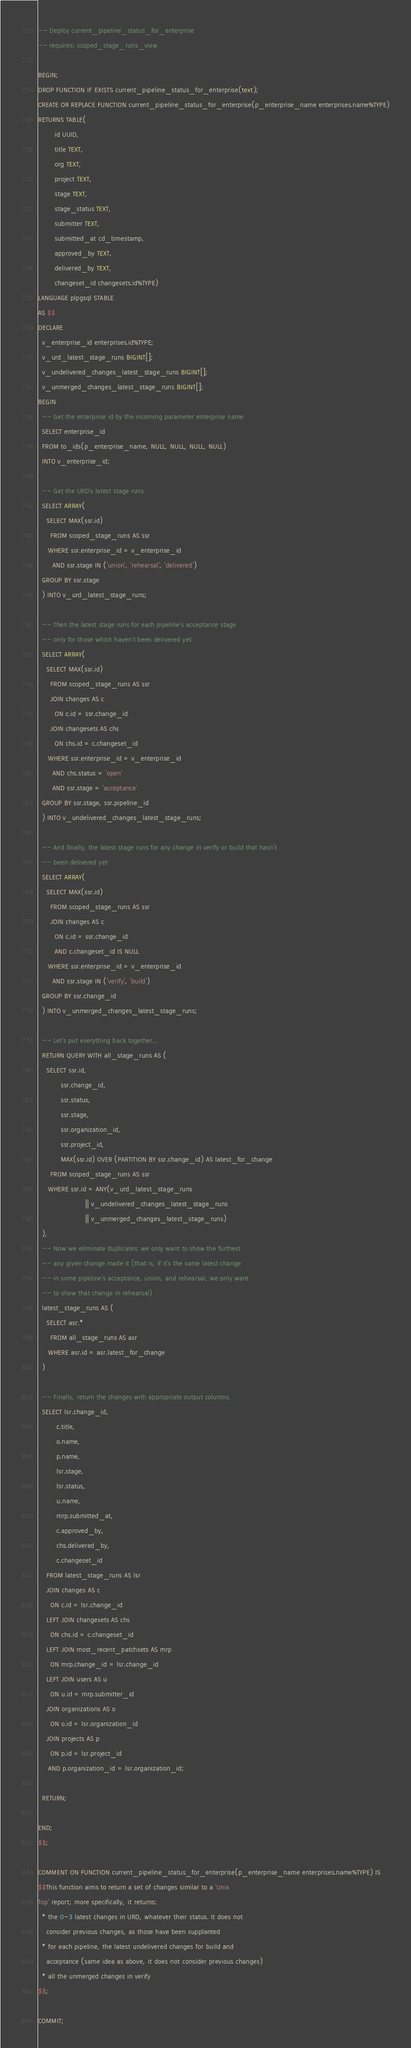<code> <loc_0><loc_0><loc_500><loc_500><_SQL_>-- Deploy current_pipeline_status_for_enterprise
-- requires: scoped_stage_runs_view

BEGIN;
DROP FUNCTION IF EXISTS current_pipeline_status_for_enterprise(text);
CREATE OR REPLACE FUNCTION current_pipeline_status_for_enterprise(p_enterprise_name enterprises.name%TYPE)
RETURNS TABLE(
        id UUID,
        title TEXT,
        org TEXT,
        project TEXT,
        stage TEXT,
        stage_status TEXT,
        submitter TEXT,
        submitted_at cd_timestamp,
        approved_by TEXT,
        delivered_by TEXT,
        changeset_id changesets.id%TYPE)
LANGUAGE plpgsql STABLE
AS $$
DECLARE
  v_enterprise_id enterprises.id%TYPE;
  v_urd_latest_stage_runs BIGINT[];
  v_undelivered_changes_latest_stage_runs BIGINT[];
  v_unmerged_changes_latest_stage_runs BIGINT[];
BEGIN
  -- Get the enterprise id by the incoming parameter enterprise name
  SELECT enterprise_id
  FROM to_ids(p_enterprise_name, NULL, NULL, NULL, NULL)
  INTO v_enterprise_id;

  -- Get the URD's latest stage runs
  SELECT ARRAY(
    SELECT MAX(ssr.id)
      FROM scoped_stage_runs AS ssr
     WHERE ssr.enterprise_id = v_enterprise_id
       AND ssr.stage IN ('union', 'rehearsal', 'delivered')
  GROUP BY ssr.stage
  ) INTO v_urd_latest_stage_runs;

  -- Then the latest stage runs for each pipeline's acceptance stage
  -- only for those which haven't been delivered yet
  SELECT ARRAY(
    SELECT MAX(ssr.id)
      FROM scoped_stage_runs AS ssr
      JOIN changes AS c
        ON c.id = ssr.change_id
      JOIN changesets AS chs
        ON chs.id = c.changeset_id
     WHERE ssr.enterprise_id = v_enterprise_id
       AND chs.status = 'open'
       AND ssr.stage = 'acceptance'
  GROUP BY ssr.stage, ssr.pipeline_id
  ) INTO v_undelivered_changes_latest_stage_runs;

  -- And finally, the latest stage runs for any change in verify or build that hasn't
  -- been delivered yet
  SELECT ARRAY(
    SELECT MAX(ssr.id)
      FROM scoped_stage_runs AS ssr
      JOIN changes AS c
        ON c.id = ssr.change_id
        AND c.changeset_id IS NULL
     WHERE ssr.enterprise_id = v_enterprise_id
       AND ssr.stage IN ('verify', 'build')
  GROUP BY ssr.change_id
  ) INTO v_unmerged_changes_latest_stage_runs;

  -- Let's put everything back together...
  RETURN QUERY WITH all_stage_runs AS (
    SELECT ssr.id,
           ssr.change_id,
           ssr.status,
           ssr.stage,
           ssr.organization_id,
           ssr.project_id,
           MAX(ssr.id) OVER (PARTITION BY ssr.change_id) AS latest_for_change
      FROM scoped_stage_runs AS ssr
     WHERE ssr.id = ANY(v_urd_latest_stage_runs
                       || v_undelivered_changes_latest_stage_runs
                       || v_unmerged_changes_latest_stage_runs)
  ),
  -- Now we eliminate duplicates: we only want to show the furthest
  -- any given change made it (that is, if it's the same latest change
  -- in some pipeline's acceptance, union, and rehearsal, we only want
  -- to show that change in rehearsal)
  latest_stage_runs AS (
    SELECT asr.*
      FROM all_stage_runs AS asr
     WHERE asr.id = asr.latest_for_change
  )

  -- Finally, return the changes with appropriate output columns.
  SELECT lsr.change_id,
         c.title,
         o.name,
         p.name,
         lsr.stage,
         lsr.status,
         u.name,
         mrp.submitted_at,
         c.approved_by,
         chs.delivered_by,
         c.changeset_id
    FROM latest_stage_runs AS lsr
    JOIN changes AS c
      ON c.id = lsr.change_id
    LEFT JOIN changesets AS chs
      ON chs.id = c.changeset_id
    LEFT JOIN most_recent_patchsets AS mrp
      ON mrp.change_id = lsr.change_id
    LEFT JOIN users AS u
      ON u.id = mrp.submitter_id
    JOIN organizations AS o
      ON o.id = lsr.organization_id
    JOIN projects AS p
      ON p.id = lsr.project_id
     AND p.organization_id = lsr.organization_id;

  RETURN;

END;
$$;

COMMENT ON FUNCTION current_pipeline_status_for_enterprise(p_enterprise_name enterprises.name%TYPE) IS
$$This function aims to return a set of changes similar to a 'Unix
Top' report; more specifically, it returns:
  * the 0-3 latest changes in URD, whatever their status. It does not
    consider previous changes, as those have been supplanted
  * for each pipeline, the latest undelivered changes for build and
    acceptance (same idea as above, it does not consider previous changes)
  * all the unmerged changes in verify
$$;

COMMIT;
</code> 